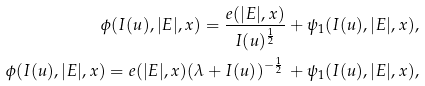<formula> <loc_0><loc_0><loc_500><loc_500>\phi ( I ( u ) , | E | , x ) = \frac { e ( | E | , x ) } { I ( u ) ^ { \frac { 1 } { 2 } } } + \psi _ { 1 } ( I ( u ) , | E | , x ) , \\ \phi ( I ( u ) , | E | , x ) = e ( | E | , x ) ( \lambda + I ( u ) ) ^ { - \frac { 1 } { 2 } } \, + \psi _ { 1 } ( I ( u ) , | E | , x ) ,</formula> 